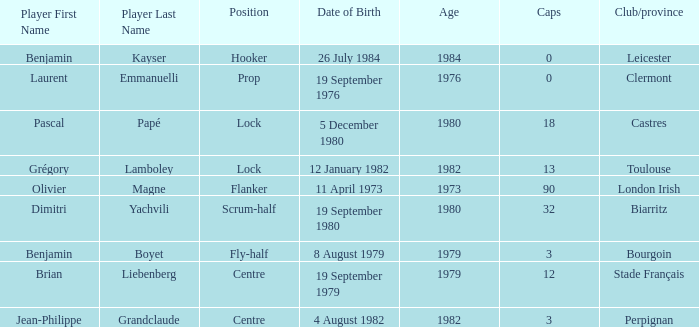Give me the full table as a dictionary. {'header': ['Player First Name', 'Player Last Name', 'Position', 'Date of Birth', 'Age', 'Caps', 'Club/province'], 'rows': [['Benjamin', 'Kayser', 'Hooker', '26 July 1984', '1984', '0', 'Leicester'], ['Laurent', 'Emmanuelli', 'Prop', '19 September 1976', '1976', '0', 'Clermont'], ['Pascal', 'Papé', 'Lock', '5 December 1980', '1980', '18', 'Castres'], ['Grégory', 'Lamboley', 'Lock', '12 January 1982', '1982', '13', 'Toulouse'], ['Olivier', 'Magne', 'Flanker', '11 April 1973', '1973', '90', 'London Irish'], ['Dimitri', 'Yachvili', 'Scrum-half', '19 September 1980', '1980', '32', 'Biarritz'], ['Benjamin', 'Boyet', 'Fly-half', '8 August 1979', '1979', '3', 'Bourgoin'], ['Brian', 'Liebenberg', 'Centre', '19 September 1979', '1979', '12', 'Stade Français'], ['Jean-Philippe', 'Grandclaude', 'Centre', '4 August 1982', '1982', '3', 'Perpignan']]} What is the position of Perpignan? Centre. 